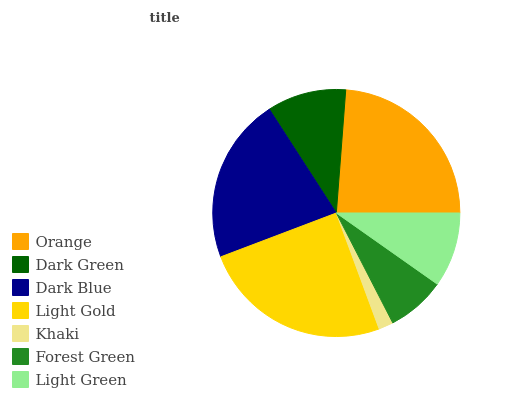Is Khaki the minimum?
Answer yes or no. Yes. Is Light Gold the maximum?
Answer yes or no. Yes. Is Dark Green the minimum?
Answer yes or no. No. Is Dark Green the maximum?
Answer yes or no. No. Is Orange greater than Dark Green?
Answer yes or no. Yes. Is Dark Green less than Orange?
Answer yes or no. Yes. Is Dark Green greater than Orange?
Answer yes or no. No. Is Orange less than Dark Green?
Answer yes or no. No. Is Dark Green the high median?
Answer yes or no. Yes. Is Dark Green the low median?
Answer yes or no. Yes. Is Forest Green the high median?
Answer yes or no. No. Is Dark Blue the low median?
Answer yes or no. No. 